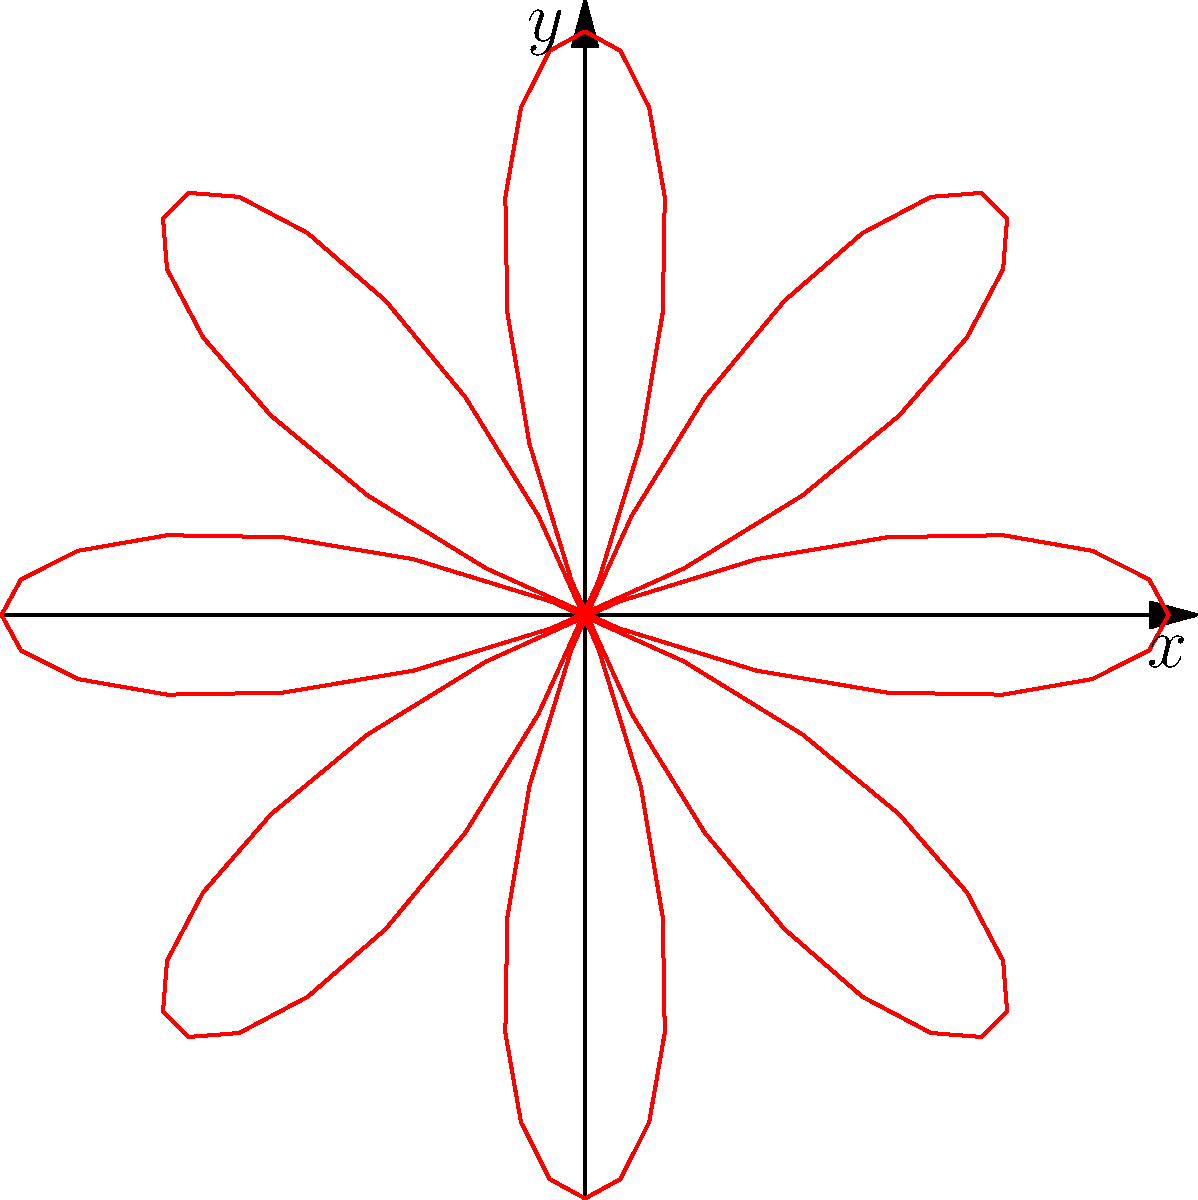As you help your child prepare for their college math courses, you come across a problem about polar rose curves. The equation $r = \cos(n\theta)$ represents a polar rose with $2n$ petals if $n$ is even, or $n$ petals if $n$ is odd. Given the polar rose curve shown above, how many petals does it have? To determine the number of petals in the polar rose curve, we need to follow these steps:

1. Observe the equation given for polar rose curves: $r = \cos(n\theta)$

2. Look at the graph and count the number of "loops" or petals. In this case, we can see 8 petals.

3. Recall the rule:
   - If $n$ is even, the number of petals is $2n$
   - If $n$ is odd, the number of petals is $n$

4. Since we have 8 petals, we know that $n$ must be even (because 8 is even).

5. To find $n$, we use the formula for even $n$: $2n = 8$

6. Solving for $n$: $n = 8/2 = 4$

7. We can verify this by looking at the equation of the curve in the Asymptote code: $r = \cos(4\theta)$

Therefore, the value of $n$ in the equation $r = \cos(n\theta)$ for this polar rose curve is 4.
Answer: 8 petals 